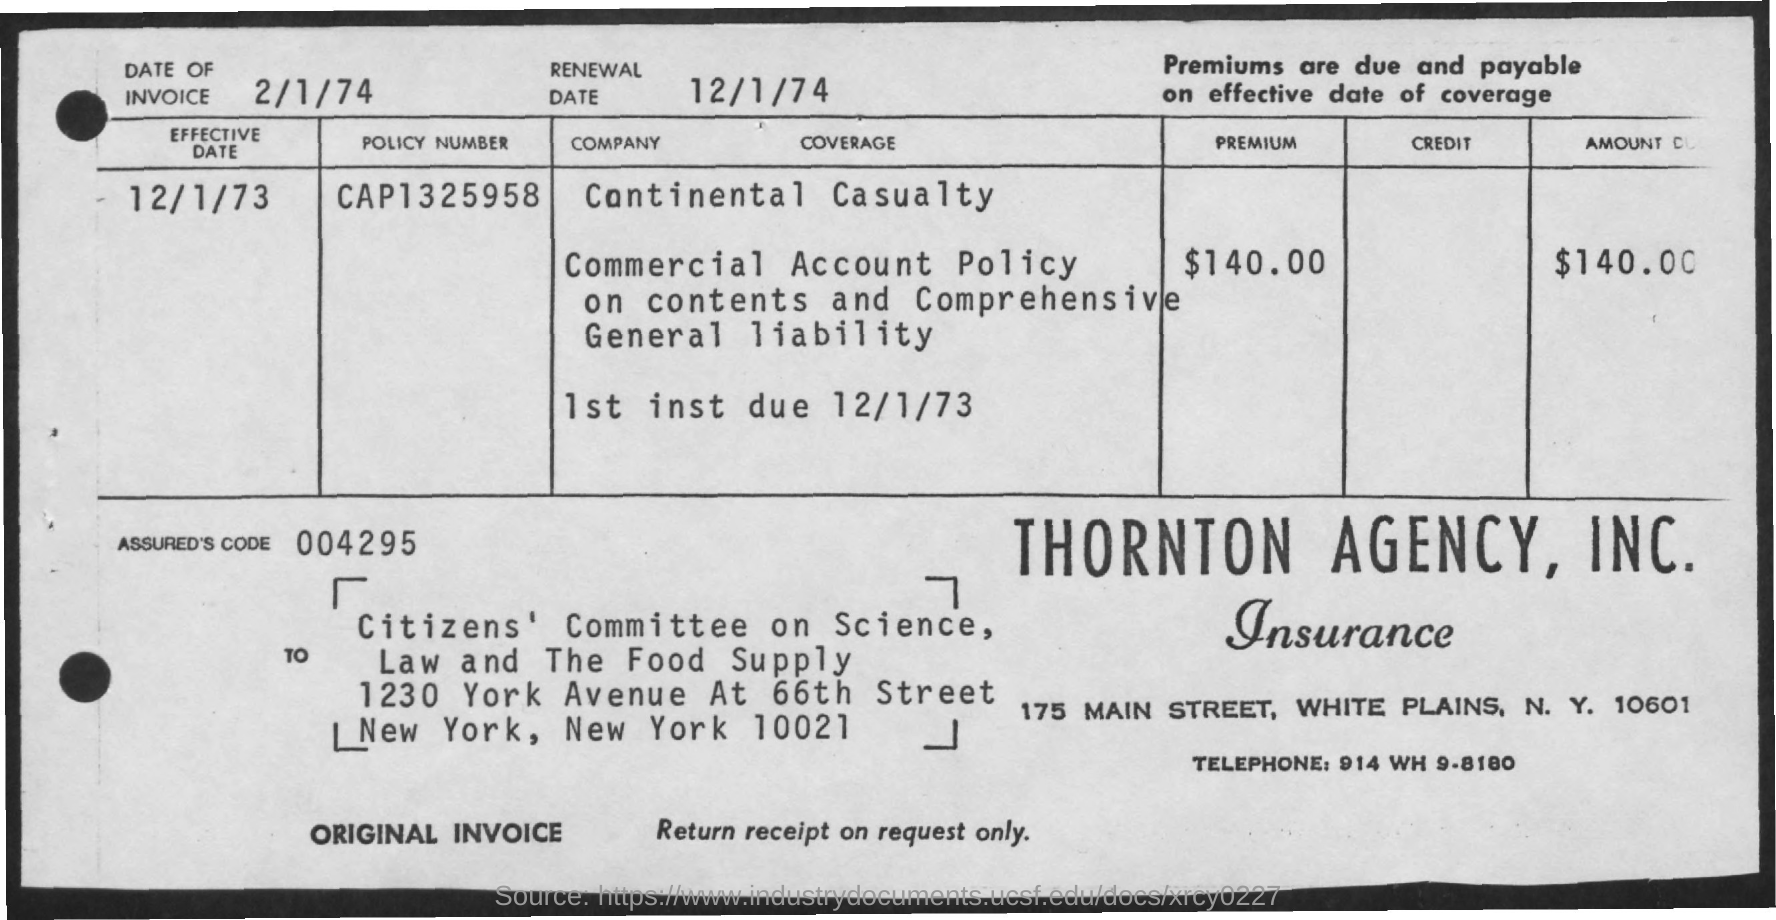What's the Telephone No.?
Give a very brief answer. 914 WH 9-8180. What is the Premium amount to be paid?
Give a very brief answer. $140.00. Name of company paying the Premium ?
Keep it short and to the point. Continental Casualty. Whats the POLICY NUMBER?
Make the answer very short. CAP1325958. When was the RENEWAL DATE?
Provide a short and direct response. 12/1/74. Whats the ASSURED'S  CODE?
Offer a very short reply. 004295. 